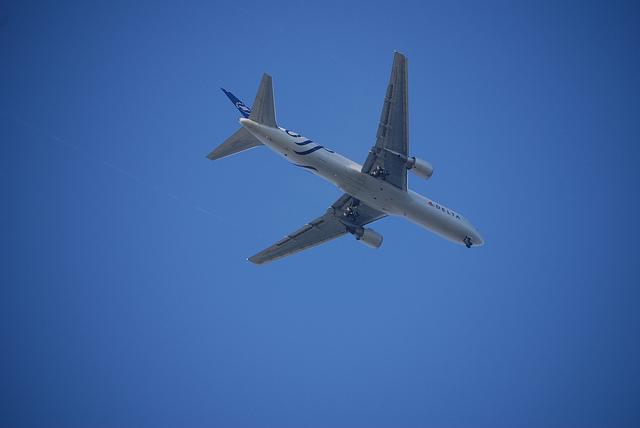How many engines on the plane?
Write a very short answer. 2. Is this a passenger plane?
Short answer required. Yes. Is the plane in the air?
Be succinct. Yes. Are there clouds in the sky?
Short answer required. No. 